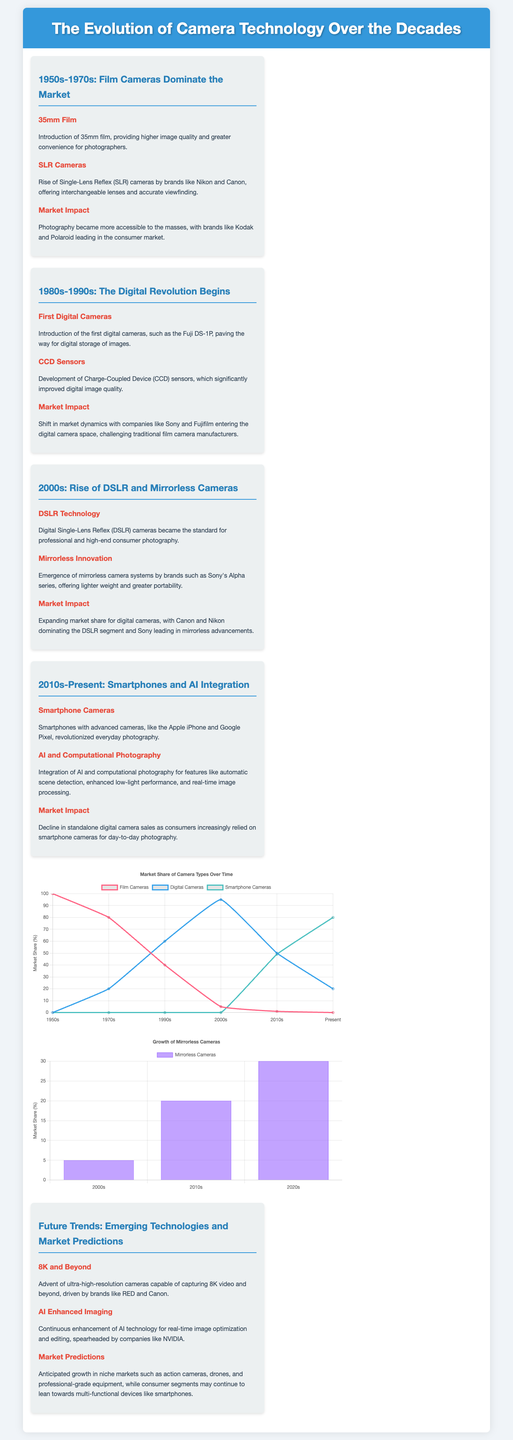What major type of camera dominated the market from the 1950s to 1970s? The document states that film cameras dominated the market during this period.
Answer: Film Cameras Which technology significantly improved digital image quality in the 1980s-1990s? The section on the 1980s-1990s details the development of Charge-Coupled Device (CCD) sensors as a key advancement.
Answer: CCD Sensors What was the market share of film cameras in the 1990s? The chart indicates that film cameras had a market share of 40% in the 1990s.
Answer: 40 Which brand was a notable leader in the mirrorless camera segment in the 2000s? The text mentions Sony's Alpha series as a key player in mirrorless camera systems during the 2000s.
Answer: Sony How much market share did mirrorless cameras capture in the 2020s? According to the bar chart, mirrorless cameras captured a 30% market share in the 2020s.
Answer: 30 What type of photography technology is integrated into modern smartphones? The document highlights AI and computational photography as key features in modern smartphones.
Answer: AI and computational photography In which decade did digital cameras begin to shift market dynamics? The 1980s-1990s section notes this shift with the introduction of the first digital cameras.
Answer: 1980s-1990s What is a predicted future trend for cameras according to the document? The text discusses the advent of ultra-high-resolution cameras as a future trend.
Answer: 8K and Beyond 